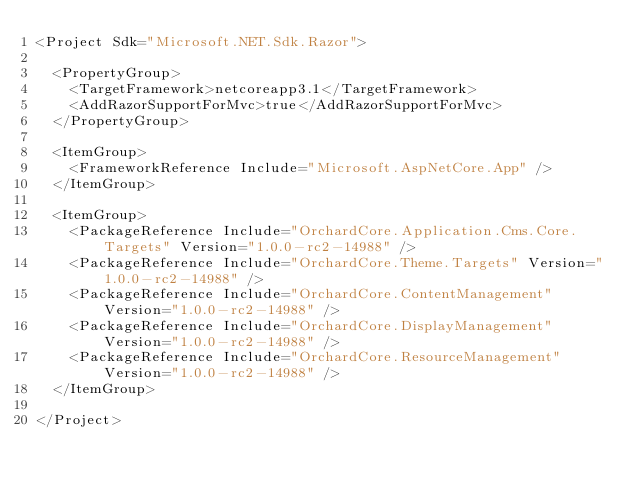<code> <loc_0><loc_0><loc_500><loc_500><_XML_><Project Sdk="Microsoft.NET.Sdk.Razor">

  <PropertyGroup>
    <TargetFramework>netcoreapp3.1</TargetFramework>
    <AddRazorSupportForMvc>true</AddRazorSupportForMvc>
  </PropertyGroup>

  <ItemGroup>
    <FrameworkReference Include="Microsoft.AspNetCore.App" />
  </ItemGroup>

  <ItemGroup>
    <PackageReference Include="OrchardCore.Application.Cms.Core.Targets" Version="1.0.0-rc2-14988" />
    <PackageReference Include="OrchardCore.Theme.Targets" Version="1.0.0-rc2-14988" />
    <PackageReference Include="OrchardCore.ContentManagement" Version="1.0.0-rc2-14988" />
    <PackageReference Include="OrchardCore.DisplayManagement" Version="1.0.0-rc2-14988" />
    <PackageReference Include="OrchardCore.ResourceManagement" Version="1.0.0-rc2-14988" />
  </ItemGroup>

</Project>
</code> 